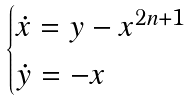Convert formula to latex. <formula><loc_0><loc_0><loc_500><loc_500>\begin{cases} \dot { x } = y - x ^ { 2 n + 1 } \\ \dot { y } = - x \end{cases}</formula> 